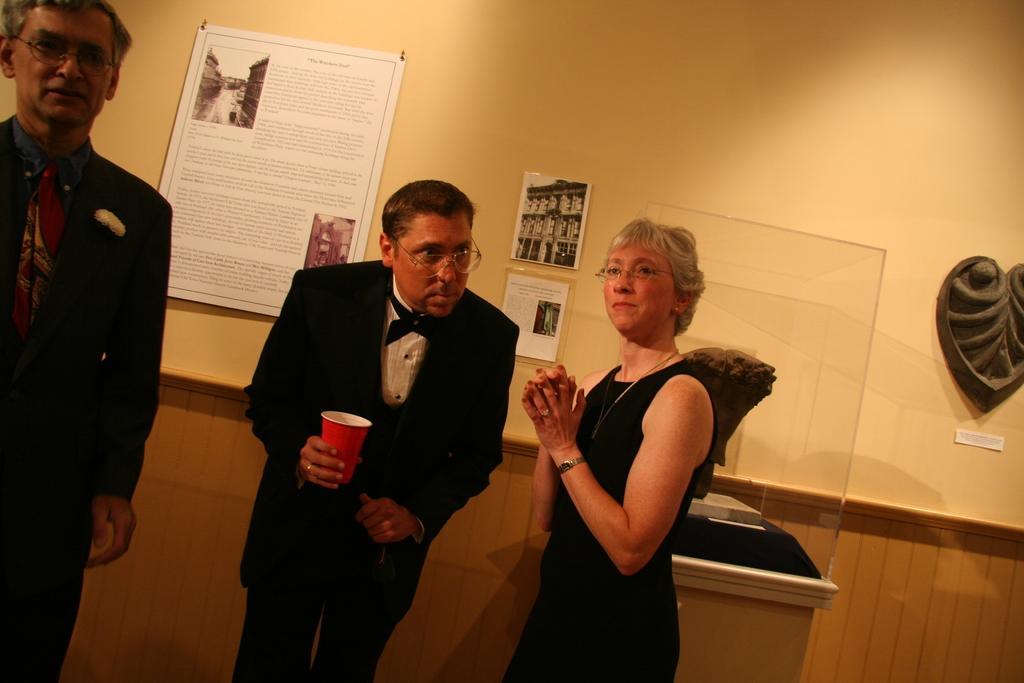In one or two sentences, can you explain what this image depicts? On the left side, there is a person in a suit, wearing a spectacle and standing. In the middle of this image, there is a person in a suit, holding a red color glass with a hand and bending slightly. Beside him, there is a woman in a black color dress, wearing a spectacle and standing. Beside her, there is an object on the table. In the background, there are posters and an object attached to a wall. 